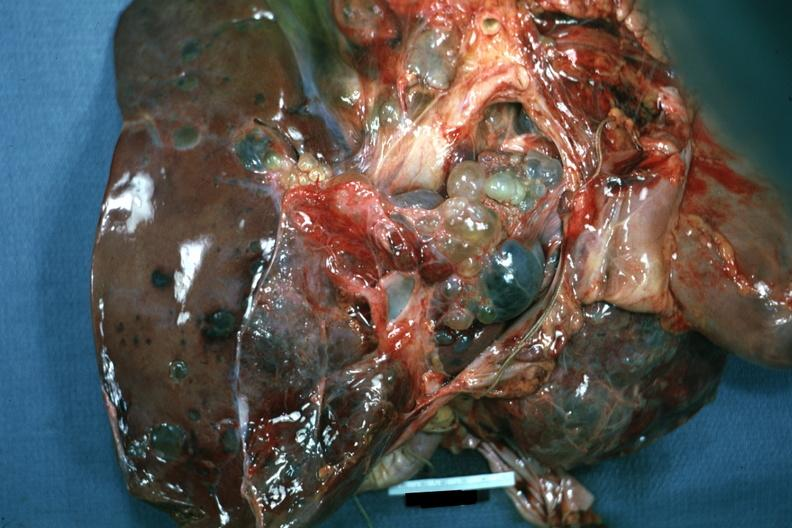what is present?
Answer the question using a single word or phrase. Hepatobiliary 